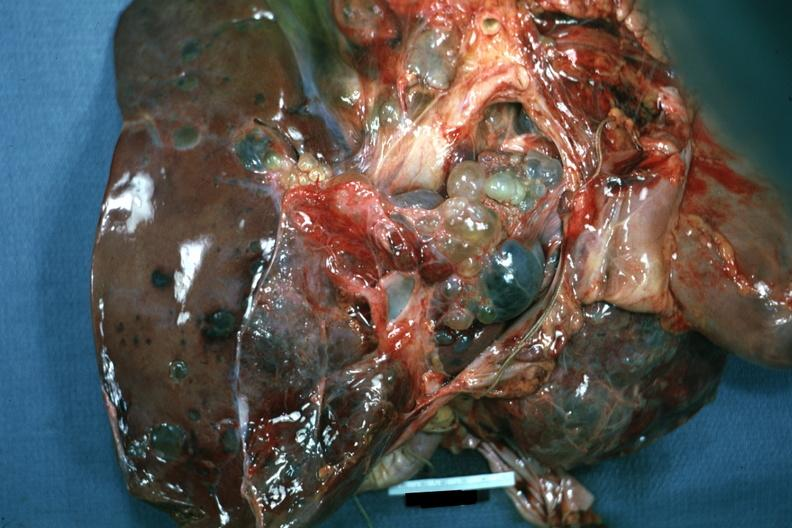what is present?
Answer the question using a single word or phrase. Hepatobiliary 